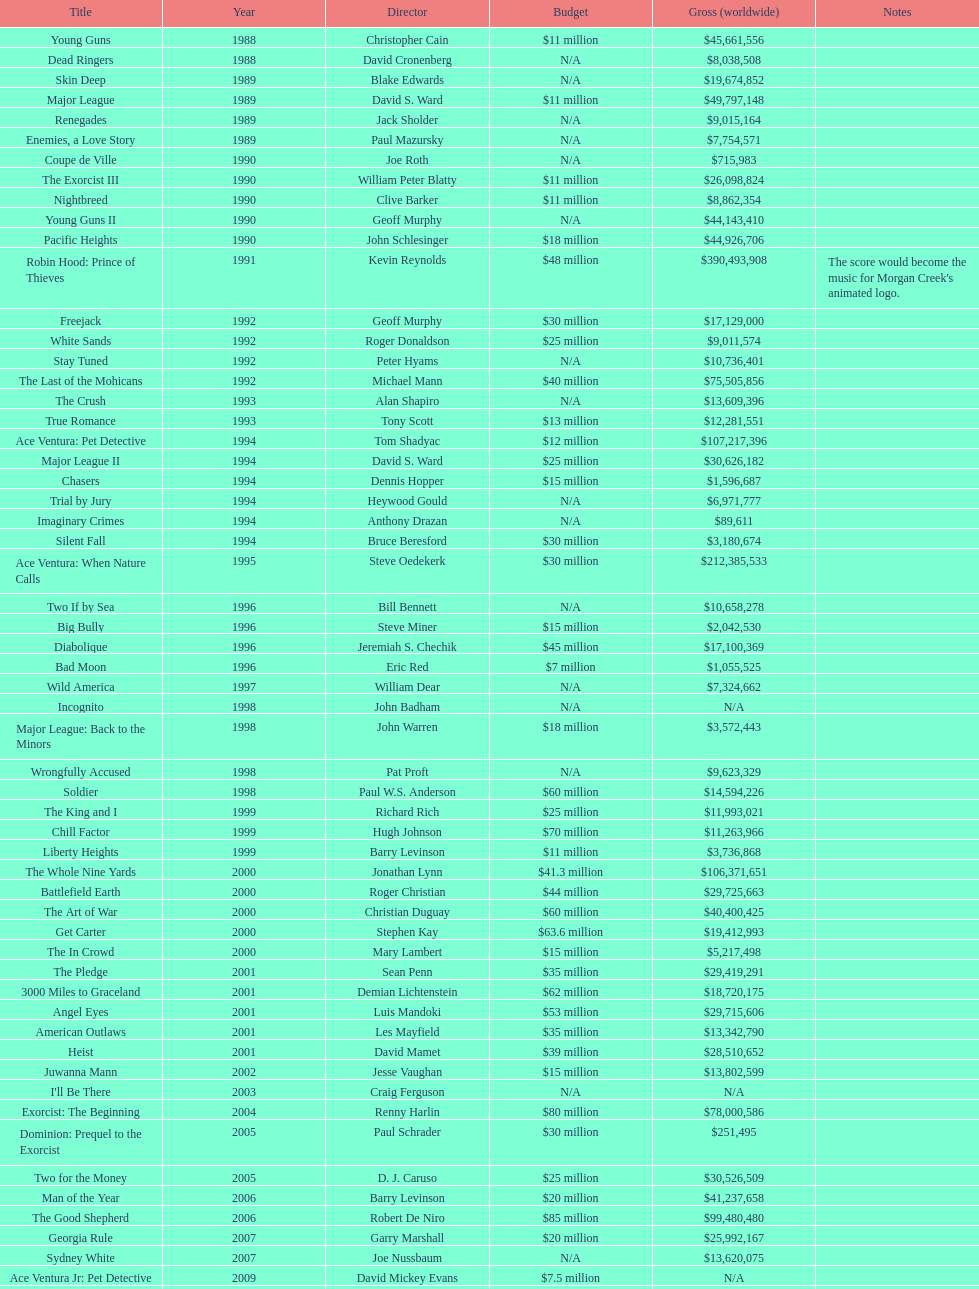Which movie holds the highest-grossing record? Robin Hood: Prince of Thieves. 